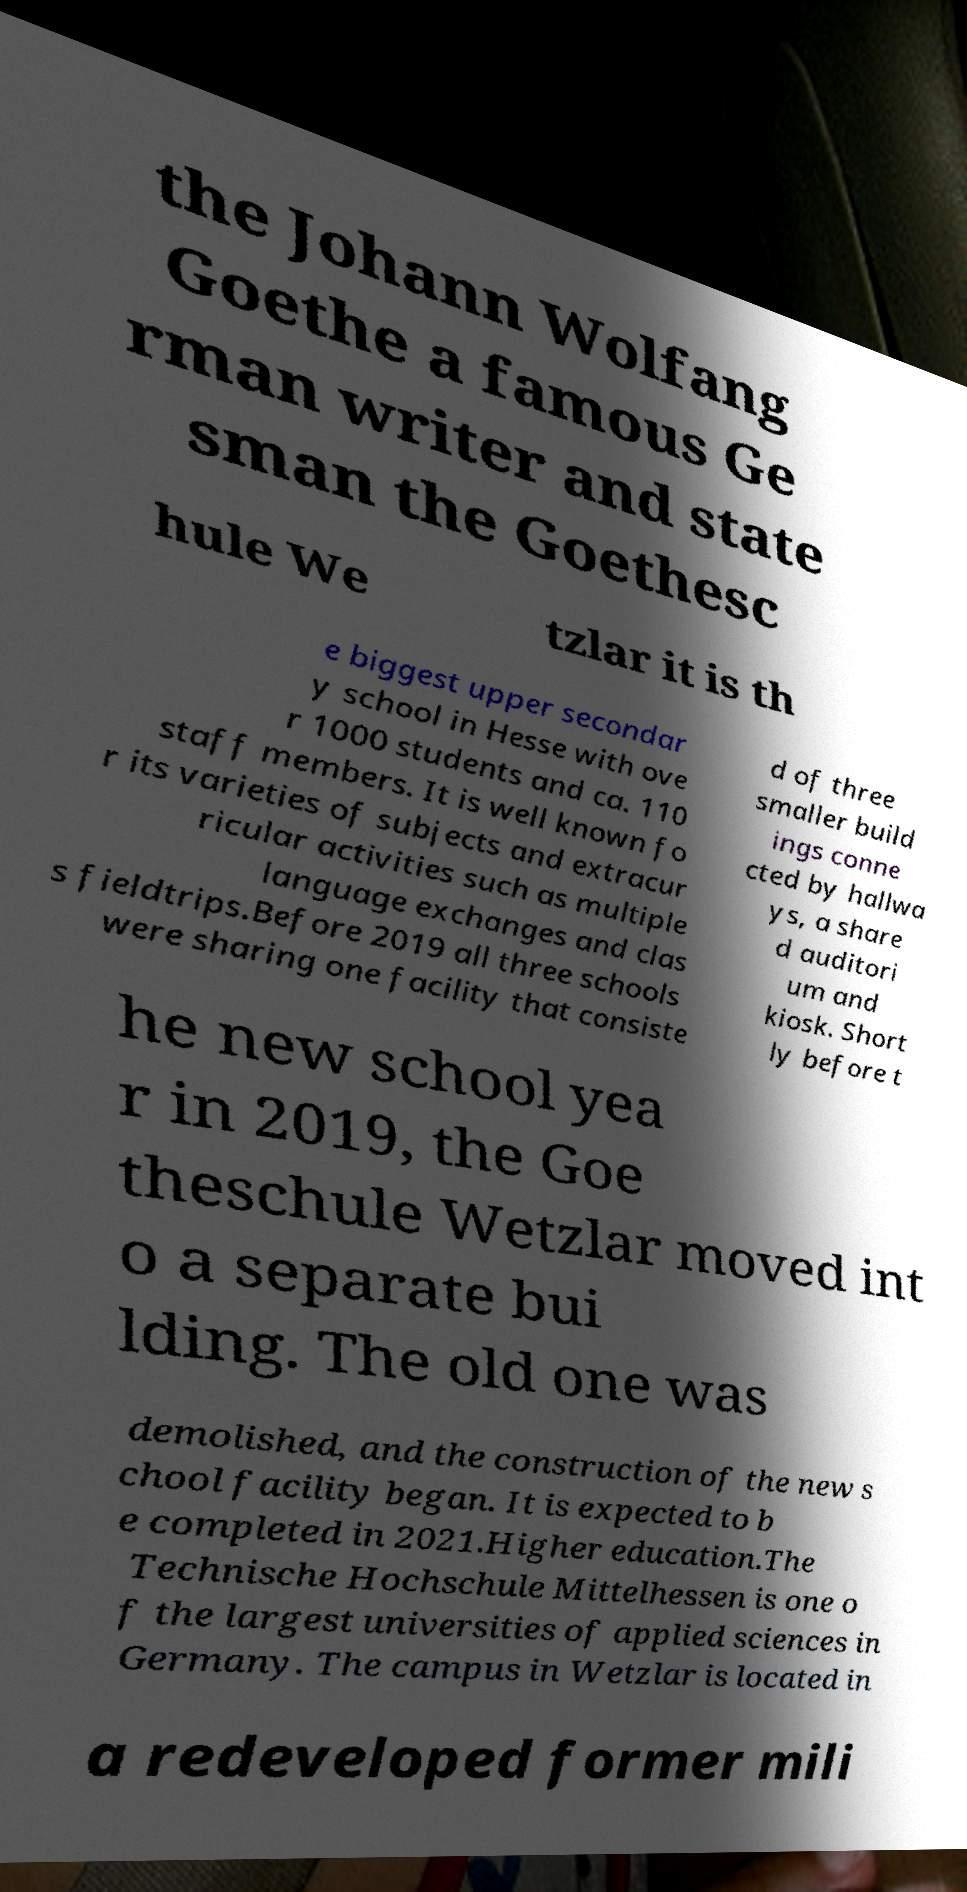Please read and relay the text visible in this image. What does it say? the Johann Wolfang Goethe a famous Ge rman writer and state sman the Goethesc hule We tzlar it is th e biggest upper secondar y school in Hesse with ove r 1000 students and ca. 110 staff members. It is well known fo r its varieties of subjects and extracur ricular activities such as multiple language exchanges and clas s fieldtrips.Before 2019 all three schools were sharing one facility that consiste d of three smaller build ings conne cted by hallwa ys, a share d auditori um and kiosk. Short ly before t he new school yea r in 2019, the Goe theschule Wetzlar moved int o a separate bui lding. The old one was demolished, and the construction of the new s chool facility began. It is expected to b e completed in 2021.Higher education.The Technische Hochschule Mittelhessen is one o f the largest universities of applied sciences in Germany. The campus in Wetzlar is located in a redeveloped former mili 